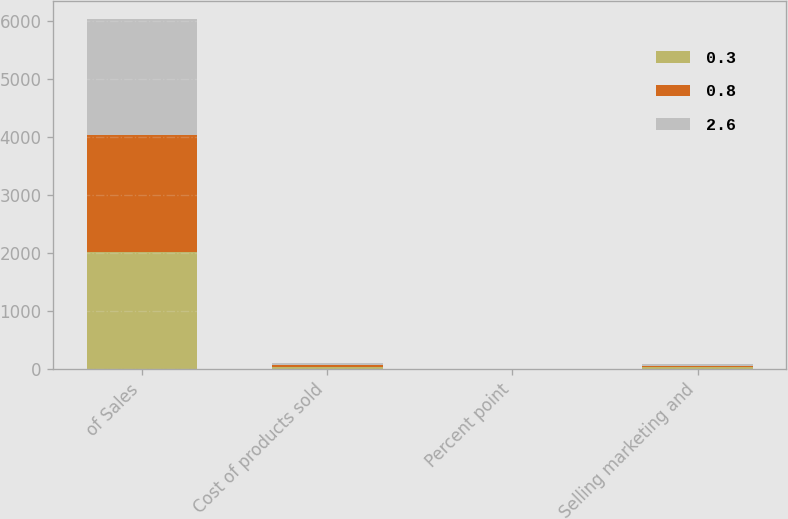Convert chart to OTSL. <chart><loc_0><loc_0><loc_500><loc_500><stacked_bar_chart><ecel><fcel>of Sales<fcel>Cost of products sold<fcel>Percent point<fcel>Selling marketing and<nl><fcel>0.3<fcel>2017<fcel>33.2<fcel>3<fcel>28<nl><fcel>0.8<fcel>2016<fcel>30.2<fcel>0.5<fcel>27.7<nl><fcel>2.6<fcel>2015<fcel>30.7<fcel>0.1<fcel>30.3<nl></chart> 